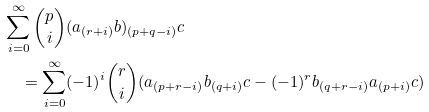<formula> <loc_0><loc_0><loc_500><loc_500>& \sum _ { i = 0 } ^ { \infty } \binom { p } { i } ( a _ { ( r + i ) } b ) _ { ( p + q - i ) } c \\ & \quad = \sum _ { i = 0 } ^ { \infty } ( - 1 ) ^ { i } \binom { r } { i } ( a _ { ( p + r - i ) } b _ { ( q + i ) } c - ( - 1 ) ^ { r } b _ { ( q + r - i ) } a _ { ( p + i ) } c )</formula> 